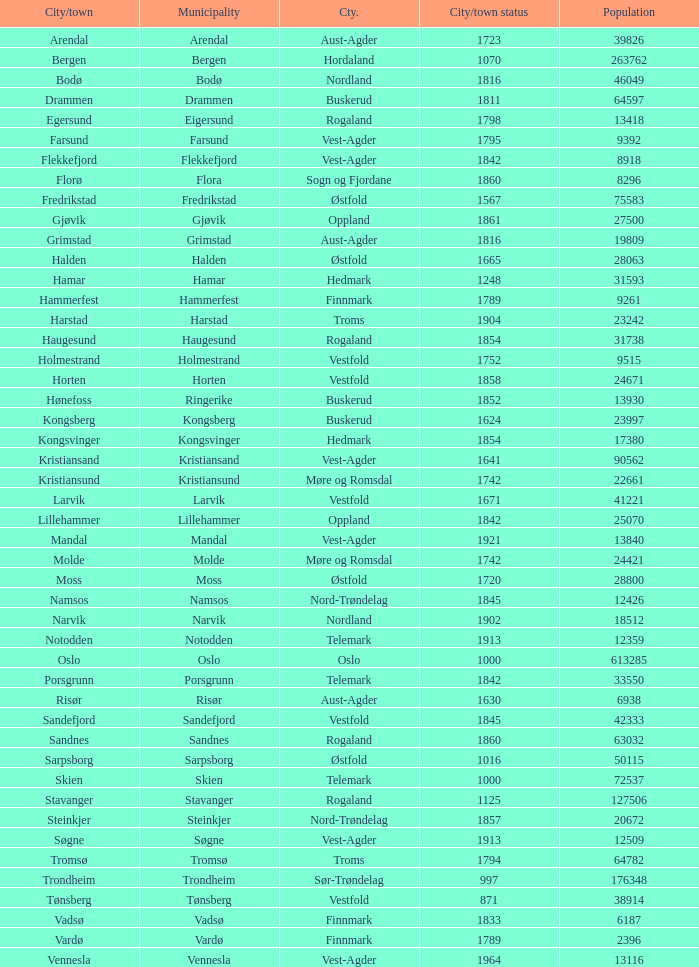What is the total population in the city/town of Arendal? 1.0. 